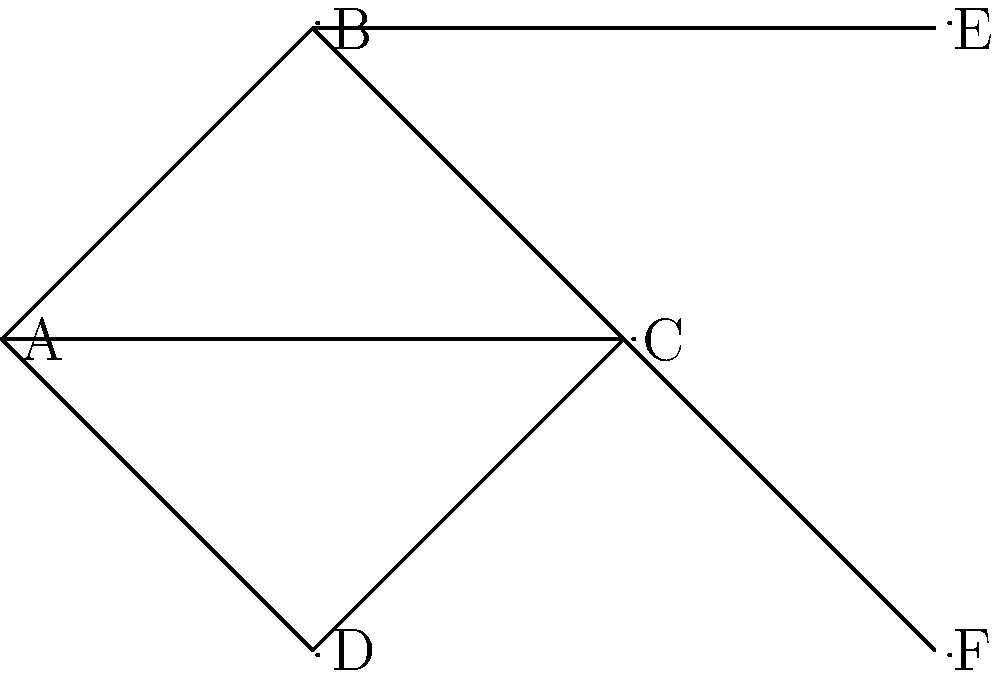In the co-authorship graph shown, where nodes represent authors and edges represent collaborations, what is the local clustering coefficient of node C? Round your answer to two decimal places. To calculate the local clustering coefficient of node C, we need to follow these steps:

1. Identify the neighbors of node C:
   Node C is connected to nodes A, B, D, and F.

2. Count the number of edges between these neighbors:
   - A is connected to B
   - A is connected to D
   - B is not connected to D
   - F is not connected to any of the other neighbors

   Total edges between neighbors = 2

3. Calculate the maximum possible edges between neighbors:
   Number of neighbors = 4
   Maximum possible edges = $\frac{4 * (4-1)}{2} = 6$

4. Apply the formula for local clustering coefficient:
   $C_i = \frac{2 * L_i}{k_i * (k_i - 1)}$

   Where:
   $C_i$ is the local clustering coefficient
   $L_i$ is the number of edges between neighbors
   $k_i$ is the number of neighbors

   $C_C = \frac{2 * 2}{4 * (4-1)} = \frac{4}{12} = 0.3333...$

5. Round to two decimal places:
   0.33

This calculation shows how interconnected the neighbors of node C are, which in the context of co-authorship, indicates how often C's collaborators work together on other projects.
Answer: 0.33 